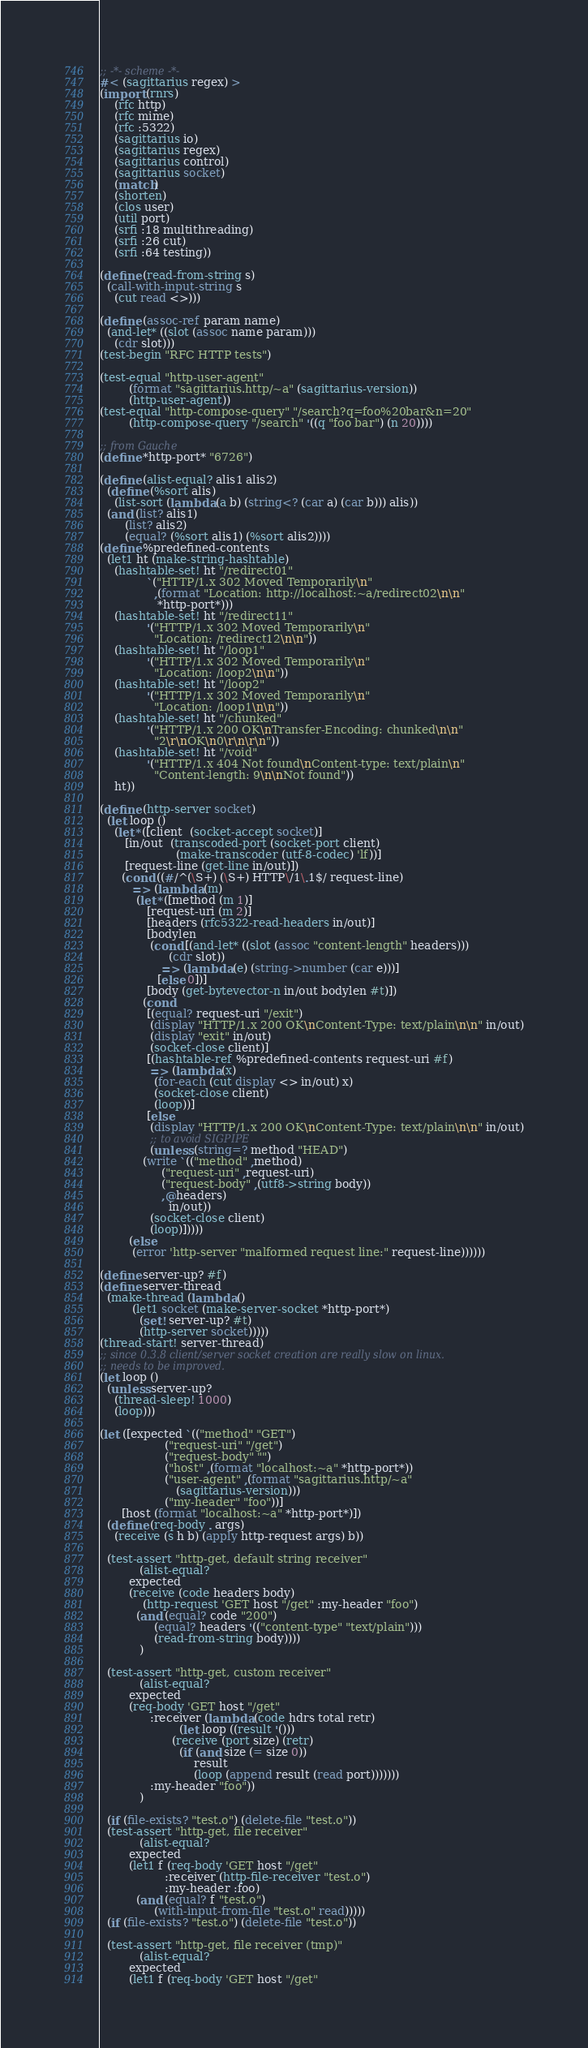<code> <loc_0><loc_0><loc_500><loc_500><_Scheme_>;; -*- scheme -*-
#< (sagittarius regex) >
(import (rnrs)
	(rfc http)
	(rfc mime)
	(rfc :5322)
	(sagittarius io)
	(sagittarius regex)
	(sagittarius control)
	(sagittarius socket)
	(match)
	(shorten)
	(clos user)
	(util port)
	(srfi :18 multithreading)
	(srfi :26 cut)
	(srfi :64 testing))

(define (read-from-string s)
  (call-with-input-string s
    (cut read <>)))

(define (assoc-ref param name)
  (and-let* ((slot (assoc name param)))
    (cdr slot)))
(test-begin "RFC HTTP tests")

(test-equal "http-user-agent"
	    (format "sagittarius.http/~a" (sagittarius-version))
	    (http-user-agent))
(test-equal "http-compose-query" "/search?q=foo%20bar&n=20"
	    (http-compose-query "/search" '((q "foo bar") (n 20))))

;; from Gauche
(define *http-port* "6726")

(define (alist-equal? alis1 alis2)
  (define (%sort alis)
    (list-sort (lambda (a b) (string<? (car a) (car b))) alis))
  (and (list? alis1)
       (list? alis2)
       (equal? (%sort alis1) (%sort alis2))))
(define %predefined-contents
  (let1 ht (make-string-hashtable)
    (hashtable-set! ht "/redirect01"
		     `("HTTP/1.x 302 Moved Temporarily\n"
		       ,(format "Location: http://localhost:~a/redirect02\n\n"
				*http-port*)))
    (hashtable-set! ht "/redirect11"
		     '("HTTP/1.x 302 Moved Temporarily\n"
		       "Location: /redirect12\n\n"))
    (hashtable-set! ht "/loop1"
		     '("HTTP/1.x 302 Moved Temporarily\n"
		       "Location: /loop2\n\n"))
    (hashtable-set! ht "/loop2"
		     '("HTTP/1.x 302 Moved Temporarily\n"
		       "Location: /loop1\n\n"))
    (hashtable-set! ht "/chunked"
		     '("HTTP/1.x 200 OK\nTransfer-Encoding: chunked\n\n"
		       "2\r\nOK\n0\r\n\r\n"))
    (hashtable-set! ht "/void"
		     '("HTTP/1.x 404 Not found\nContent-type: text/plain\n"
		       "Content-length: 9\n\nNot found"))
    ht))

(define (http-server socket)
  (let loop ()
    (let* ([client  (socket-accept socket)]
	   [in/out  (transcoded-port (socket-port client)
				     (make-transcoder (utf-8-codec) 'lf))]
	   [request-line (get-line in/out)])
      (cond ((#/^(\S+) (\S+) HTTP\/1\.1$/ request-line)
	     => (lambda (m)
		  (let* ([method (m 1)]
			 [request-uri (m 2)]
			 [headers (rfc5322-read-headers in/out)]
			 [bodylen
			  (cond [(and-let* ((slot (assoc "content-length" headers)))
				   (cdr slot))
				 => (lambda (e) (string->number (car e)))]
				[else 0])]
			 [body (get-bytevector-n in/out bodylen #t)])
		    (cond
		     [(equal? request-uri "/exit")
		      (display "HTTP/1.x 200 OK\nContent-Type: text/plain\n\n" in/out)
		      (display "exit" in/out)
		      (socket-close client)]
		     [(hashtable-ref %predefined-contents request-uri #f)
		      => (lambda (x)
			   (for-each (cut display <> in/out) x)
			   (socket-close client)
			   (loop))]
		     [else
		      (display "HTTP/1.x 200 OK\nContent-Type: text/plain\n\n" in/out)
		      ;; to avoid SIGPIPE
		      (unless (string=? method "HEAD")
			(write `(("method" ,method)
				 ("request-uri" ,request-uri)
				 ("request-body" ,(utf8->string body))
				 ,@headers)
			       in/out))
		      (socket-close client)
		      (loop)]))))
	    (else
	     (error 'http-server "malformed request line:" request-line))))))

(define server-up? #f)
(define server-thread
  (make-thread (lambda ()
		 (let1 socket (make-server-socket *http-port*)
		   (set! server-up? #t)
		   (http-server socket)))))
(thread-start! server-thread)
;; since 0.3.8 client/server socket creation are really slow on linux.
;; needs to be improved.
(let loop ()
  (unless server-up?
    (thread-sleep! 1000)
    (loop)))

(let ([expected `(("method" "GET")
                  ("request-uri" "/get")
                  ("request-body" "")
                  ("host" ,(format "localhost:~a" *http-port*))
                  ("user-agent" ,(format "sagittarius.http/~a"
					 (sagittarius-version)))
                  ("my-header" "foo"))]
      [host (format "localhost:~a" *http-port*)])
  (define (req-body . args)
    (receive (s h b) (apply http-request args) b))

  (test-assert "http-get, default string receiver"
	       (alist-equal? 
		expected
		(receive (code headers body)
		    (http-request 'GET host "/get" :my-header "foo")
		  (and (equal? code "200")
		       (equal? headers '(("content-type" "text/plain")))
		       (read-from-string body))))
	       )

  (test-assert "http-get, custom receiver"
	       (alist-equal?
		expected
		(req-body 'GET host "/get"
			  :receiver (lambda (code hdrs total retr)
				      (let loop ((result '()))
					(receive (port size) (retr)
					  (if (and size (= size 0))
					      result
					      (loop (append result (read port)))))))
			  :my-header "foo"))
	       )

  (if (file-exists? "test.o") (delete-file "test.o"))
  (test-assert "http-get, file receiver" 
	       (alist-equal?
		expected
		(let1 f (req-body 'GET host "/get"
				  :receiver (http-file-receiver "test.o")
				  :my-header :foo)
		  (and (equal? f "test.o")
		       (with-input-from-file "test.o" read)))))
  (if (file-exists? "test.o") (delete-file "test.o"))

  (test-assert "http-get, file receiver (tmp)" 
	       (alist-equal?
		expected
		(let1 f (req-body 'GET host "/get"</code> 